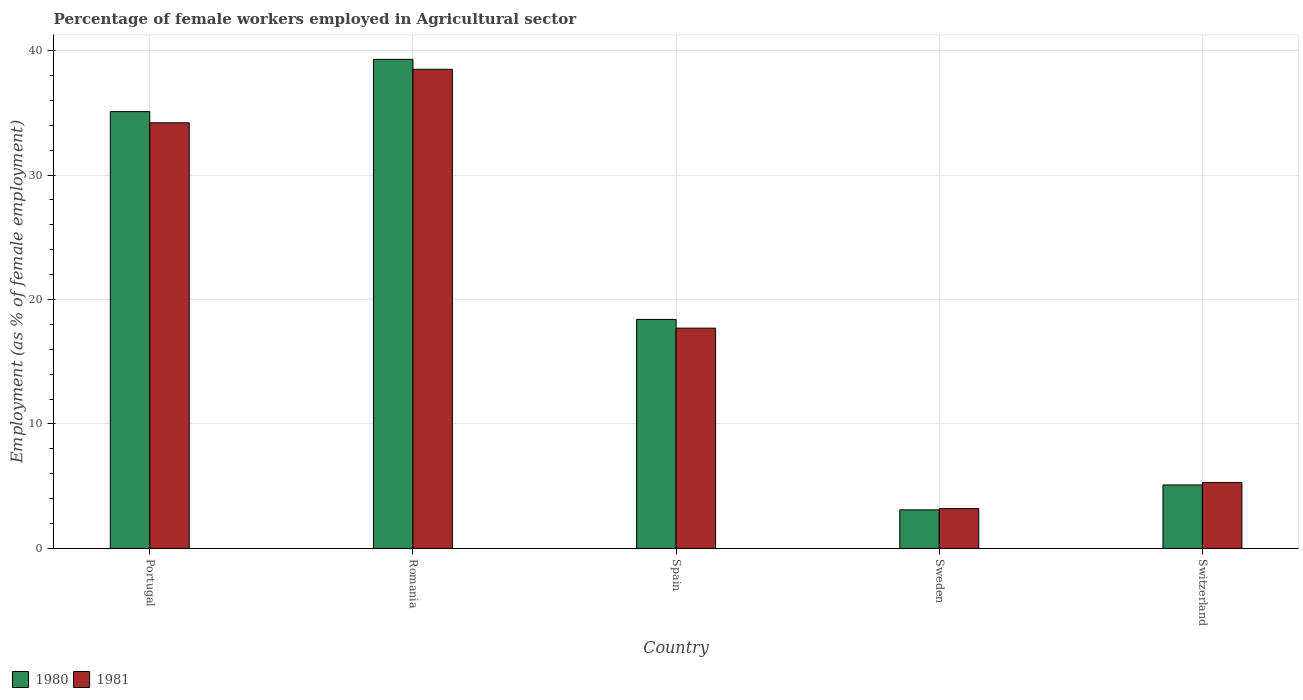How many different coloured bars are there?
Offer a terse response. 2. How many groups of bars are there?
Your response must be concise. 5. Are the number of bars on each tick of the X-axis equal?
Ensure brevity in your answer.  Yes. How many bars are there on the 1st tick from the right?
Your answer should be compact. 2. In how many cases, is the number of bars for a given country not equal to the number of legend labels?
Keep it short and to the point. 0. What is the percentage of females employed in Agricultural sector in 1980 in Switzerland?
Offer a terse response. 5.1. Across all countries, what is the maximum percentage of females employed in Agricultural sector in 1980?
Keep it short and to the point. 39.3. Across all countries, what is the minimum percentage of females employed in Agricultural sector in 1980?
Your response must be concise. 3.1. In which country was the percentage of females employed in Agricultural sector in 1980 maximum?
Ensure brevity in your answer.  Romania. In which country was the percentage of females employed in Agricultural sector in 1981 minimum?
Provide a short and direct response. Sweden. What is the total percentage of females employed in Agricultural sector in 1980 in the graph?
Make the answer very short. 101. What is the difference between the percentage of females employed in Agricultural sector in 1980 in Spain and that in Switzerland?
Your answer should be compact. 13.3. What is the difference between the percentage of females employed in Agricultural sector in 1980 in Switzerland and the percentage of females employed in Agricultural sector in 1981 in Portugal?
Your response must be concise. -29.1. What is the average percentage of females employed in Agricultural sector in 1981 per country?
Your answer should be very brief. 19.78. What is the difference between the percentage of females employed in Agricultural sector of/in 1980 and percentage of females employed in Agricultural sector of/in 1981 in Spain?
Your response must be concise. 0.7. What is the ratio of the percentage of females employed in Agricultural sector in 1981 in Portugal to that in Sweden?
Make the answer very short. 10.69. Is the percentage of females employed in Agricultural sector in 1980 in Portugal less than that in Sweden?
Your response must be concise. No. What is the difference between the highest and the second highest percentage of females employed in Agricultural sector in 1981?
Keep it short and to the point. -16.5. What is the difference between the highest and the lowest percentage of females employed in Agricultural sector in 1981?
Give a very brief answer. 35.3. In how many countries, is the percentage of females employed in Agricultural sector in 1981 greater than the average percentage of females employed in Agricultural sector in 1981 taken over all countries?
Give a very brief answer. 2. What does the 1st bar from the left in Spain represents?
Your response must be concise. 1980. What does the 1st bar from the right in Switzerland represents?
Offer a terse response. 1981. How many bars are there?
Make the answer very short. 10. How many countries are there in the graph?
Make the answer very short. 5. What is the difference between two consecutive major ticks on the Y-axis?
Offer a very short reply. 10. How many legend labels are there?
Provide a succinct answer. 2. How are the legend labels stacked?
Offer a very short reply. Horizontal. What is the title of the graph?
Your answer should be compact. Percentage of female workers employed in Agricultural sector. Does "1990" appear as one of the legend labels in the graph?
Your answer should be compact. No. What is the label or title of the X-axis?
Offer a very short reply. Country. What is the label or title of the Y-axis?
Keep it short and to the point. Employment (as % of female employment). What is the Employment (as % of female employment) of 1980 in Portugal?
Offer a terse response. 35.1. What is the Employment (as % of female employment) in 1981 in Portugal?
Make the answer very short. 34.2. What is the Employment (as % of female employment) in 1980 in Romania?
Your answer should be compact. 39.3. What is the Employment (as % of female employment) of 1981 in Romania?
Give a very brief answer. 38.5. What is the Employment (as % of female employment) in 1980 in Spain?
Make the answer very short. 18.4. What is the Employment (as % of female employment) in 1981 in Spain?
Your answer should be very brief. 17.7. What is the Employment (as % of female employment) of 1980 in Sweden?
Your response must be concise. 3.1. What is the Employment (as % of female employment) of 1981 in Sweden?
Your answer should be very brief. 3.2. What is the Employment (as % of female employment) in 1980 in Switzerland?
Give a very brief answer. 5.1. What is the Employment (as % of female employment) of 1981 in Switzerland?
Give a very brief answer. 5.3. Across all countries, what is the maximum Employment (as % of female employment) of 1980?
Keep it short and to the point. 39.3. Across all countries, what is the maximum Employment (as % of female employment) in 1981?
Provide a short and direct response. 38.5. Across all countries, what is the minimum Employment (as % of female employment) of 1980?
Your answer should be very brief. 3.1. Across all countries, what is the minimum Employment (as % of female employment) of 1981?
Offer a very short reply. 3.2. What is the total Employment (as % of female employment) in 1980 in the graph?
Your answer should be compact. 101. What is the total Employment (as % of female employment) of 1981 in the graph?
Your answer should be very brief. 98.9. What is the difference between the Employment (as % of female employment) in 1980 in Portugal and that in Romania?
Offer a terse response. -4.2. What is the difference between the Employment (as % of female employment) in 1981 in Portugal and that in Romania?
Provide a succinct answer. -4.3. What is the difference between the Employment (as % of female employment) in 1981 in Portugal and that in Spain?
Keep it short and to the point. 16.5. What is the difference between the Employment (as % of female employment) in 1980 in Portugal and that in Sweden?
Your answer should be compact. 32. What is the difference between the Employment (as % of female employment) in 1981 in Portugal and that in Switzerland?
Offer a very short reply. 28.9. What is the difference between the Employment (as % of female employment) of 1980 in Romania and that in Spain?
Offer a terse response. 20.9. What is the difference between the Employment (as % of female employment) in 1981 in Romania and that in Spain?
Make the answer very short. 20.8. What is the difference between the Employment (as % of female employment) in 1980 in Romania and that in Sweden?
Your response must be concise. 36.2. What is the difference between the Employment (as % of female employment) in 1981 in Romania and that in Sweden?
Your response must be concise. 35.3. What is the difference between the Employment (as % of female employment) of 1980 in Romania and that in Switzerland?
Provide a short and direct response. 34.2. What is the difference between the Employment (as % of female employment) in 1981 in Romania and that in Switzerland?
Your response must be concise. 33.2. What is the difference between the Employment (as % of female employment) of 1981 in Spain and that in Sweden?
Keep it short and to the point. 14.5. What is the difference between the Employment (as % of female employment) in 1981 in Sweden and that in Switzerland?
Provide a succinct answer. -2.1. What is the difference between the Employment (as % of female employment) of 1980 in Portugal and the Employment (as % of female employment) of 1981 in Romania?
Offer a very short reply. -3.4. What is the difference between the Employment (as % of female employment) of 1980 in Portugal and the Employment (as % of female employment) of 1981 in Sweden?
Your answer should be compact. 31.9. What is the difference between the Employment (as % of female employment) of 1980 in Portugal and the Employment (as % of female employment) of 1981 in Switzerland?
Give a very brief answer. 29.8. What is the difference between the Employment (as % of female employment) in 1980 in Romania and the Employment (as % of female employment) in 1981 in Spain?
Offer a terse response. 21.6. What is the difference between the Employment (as % of female employment) of 1980 in Romania and the Employment (as % of female employment) of 1981 in Sweden?
Your answer should be compact. 36.1. What is the difference between the Employment (as % of female employment) of 1980 in Spain and the Employment (as % of female employment) of 1981 in Sweden?
Your answer should be very brief. 15.2. What is the difference between the Employment (as % of female employment) in 1980 in Sweden and the Employment (as % of female employment) in 1981 in Switzerland?
Give a very brief answer. -2.2. What is the average Employment (as % of female employment) in 1980 per country?
Offer a terse response. 20.2. What is the average Employment (as % of female employment) in 1981 per country?
Give a very brief answer. 19.78. What is the difference between the Employment (as % of female employment) of 1980 and Employment (as % of female employment) of 1981 in Romania?
Keep it short and to the point. 0.8. What is the difference between the Employment (as % of female employment) in 1980 and Employment (as % of female employment) in 1981 in Spain?
Ensure brevity in your answer.  0.7. What is the difference between the Employment (as % of female employment) in 1980 and Employment (as % of female employment) in 1981 in Sweden?
Ensure brevity in your answer.  -0.1. What is the ratio of the Employment (as % of female employment) of 1980 in Portugal to that in Romania?
Your answer should be very brief. 0.89. What is the ratio of the Employment (as % of female employment) of 1981 in Portugal to that in Romania?
Keep it short and to the point. 0.89. What is the ratio of the Employment (as % of female employment) of 1980 in Portugal to that in Spain?
Ensure brevity in your answer.  1.91. What is the ratio of the Employment (as % of female employment) in 1981 in Portugal to that in Spain?
Provide a short and direct response. 1.93. What is the ratio of the Employment (as % of female employment) in 1980 in Portugal to that in Sweden?
Keep it short and to the point. 11.32. What is the ratio of the Employment (as % of female employment) of 1981 in Portugal to that in Sweden?
Give a very brief answer. 10.69. What is the ratio of the Employment (as % of female employment) of 1980 in Portugal to that in Switzerland?
Your response must be concise. 6.88. What is the ratio of the Employment (as % of female employment) of 1981 in Portugal to that in Switzerland?
Provide a succinct answer. 6.45. What is the ratio of the Employment (as % of female employment) of 1980 in Romania to that in Spain?
Keep it short and to the point. 2.14. What is the ratio of the Employment (as % of female employment) of 1981 in Romania to that in Spain?
Offer a terse response. 2.18. What is the ratio of the Employment (as % of female employment) of 1980 in Romania to that in Sweden?
Provide a short and direct response. 12.68. What is the ratio of the Employment (as % of female employment) in 1981 in Romania to that in Sweden?
Your response must be concise. 12.03. What is the ratio of the Employment (as % of female employment) in 1980 in Romania to that in Switzerland?
Offer a very short reply. 7.71. What is the ratio of the Employment (as % of female employment) of 1981 in Romania to that in Switzerland?
Ensure brevity in your answer.  7.26. What is the ratio of the Employment (as % of female employment) in 1980 in Spain to that in Sweden?
Give a very brief answer. 5.94. What is the ratio of the Employment (as % of female employment) of 1981 in Spain to that in Sweden?
Offer a terse response. 5.53. What is the ratio of the Employment (as % of female employment) in 1980 in Spain to that in Switzerland?
Offer a terse response. 3.61. What is the ratio of the Employment (as % of female employment) in 1981 in Spain to that in Switzerland?
Ensure brevity in your answer.  3.34. What is the ratio of the Employment (as % of female employment) of 1980 in Sweden to that in Switzerland?
Keep it short and to the point. 0.61. What is the ratio of the Employment (as % of female employment) in 1981 in Sweden to that in Switzerland?
Your answer should be very brief. 0.6. What is the difference between the highest and the second highest Employment (as % of female employment) in 1980?
Provide a short and direct response. 4.2. What is the difference between the highest and the lowest Employment (as % of female employment) in 1980?
Your answer should be very brief. 36.2. What is the difference between the highest and the lowest Employment (as % of female employment) in 1981?
Keep it short and to the point. 35.3. 